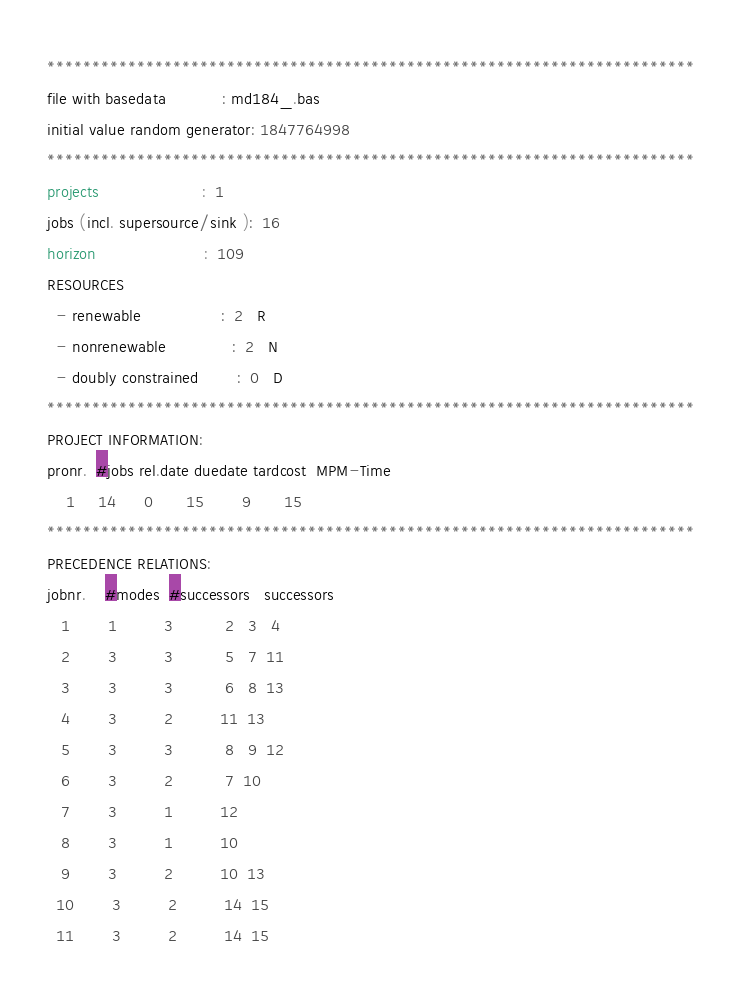Convert code to text. <code><loc_0><loc_0><loc_500><loc_500><_ObjectiveC_>************************************************************************
file with basedata            : md184_.bas
initial value random generator: 1847764998
************************************************************************
projects                      :  1
jobs (incl. supersource/sink ):  16
horizon                       :  109
RESOURCES
  - renewable                 :  2   R
  - nonrenewable              :  2   N
  - doubly constrained        :  0   D
************************************************************************
PROJECT INFORMATION:
pronr.  #jobs rel.date duedate tardcost  MPM-Time
    1     14      0       15        9       15
************************************************************************
PRECEDENCE RELATIONS:
jobnr.    #modes  #successors   successors
   1        1          3           2   3   4
   2        3          3           5   7  11
   3        3          3           6   8  13
   4        3          2          11  13
   5        3          3           8   9  12
   6        3          2           7  10
   7        3          1          12
   8        3          1          10
   9        3          2          10  13
  10        3          2          14  15
  11        3          2          14  15</code> 